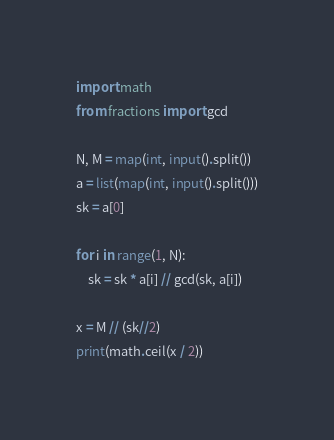<code> <loc_0><loc_0><loc_500><loc_500><_Python_>import math
from fractions import gcd

N, M = map(int, input().split())
a = list(map(int, input().split()))
sk = a[0]

for i in range(1, N):
    sk = sk * a[i] // gcd(sk, a[i])

x = M // (sk//2)
print(math.ceil(x / 2))</code> 